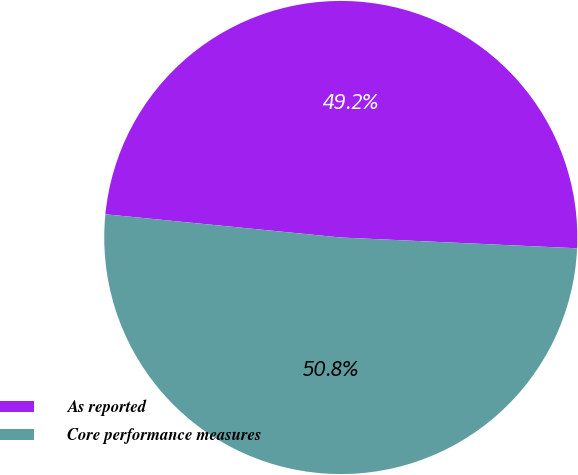Convert chart. <chart><loc_0><loc_0><loc_500><loc_500><pie_chart><fcel>As reported<fcel>Core performance measures<nl><fcel>49.16%<fcel>50.84%<nl></chart> 